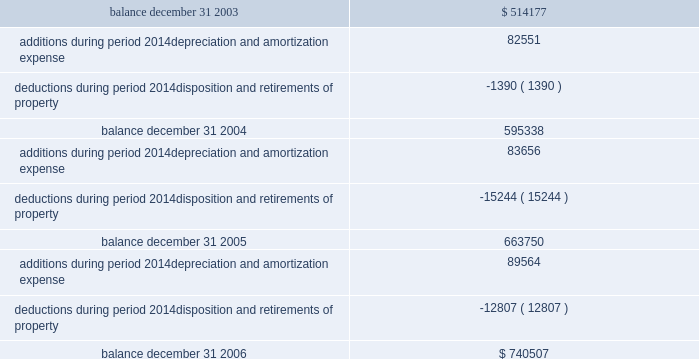Federal realty investment trust schedule iii summary of real estate and accumulated depreciation 2014continued three years ended december 31 , 2006 reconciliation of accumulated depreciation and amortization ( in thousands ) .

What was the percentual increase in the additions during 2004 and 2005? 
Rationale: it is the value of the addition in 2005 divided by the value in 2004 , then subtracted 1 and turned into a percentage .
Computations: ((83656 / 82551) - 1)
Answer: 0.01339. 